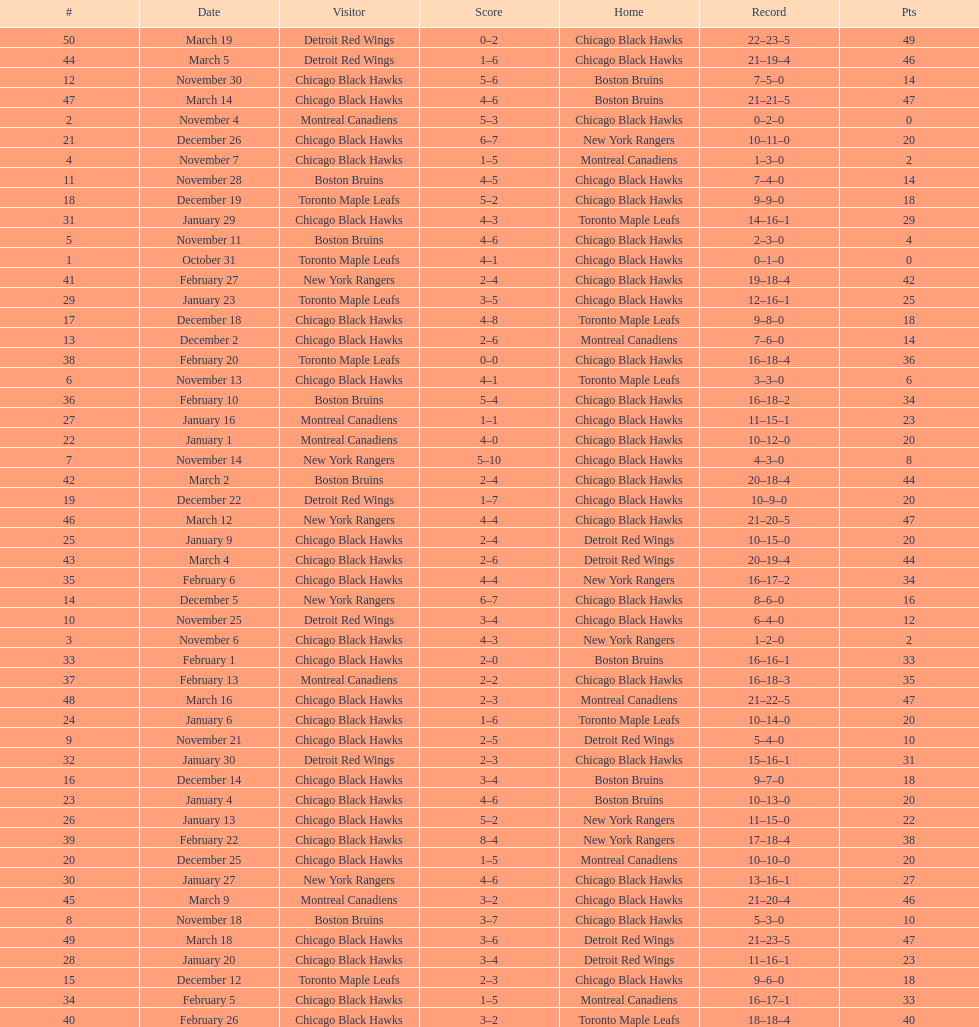Tell me the number of points the blackhawks had on march 4. 44. 